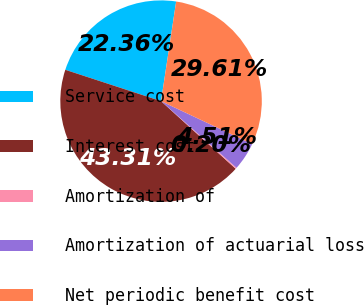Convert chart to OTSL. <chart><loc_0><loc_0><loc_500><loc_500><pie_chart><fcel>Service cost<fcel>Interest cost<fcel>Amortization of<fcel>Amortization of actuarial loss<fcel>Net periodic benefit cost<nl><fcel>22.36%<fcel>43.31%<fcel>0.2%<fcel>4.51%<fcel>29.61%<nl></chart> 